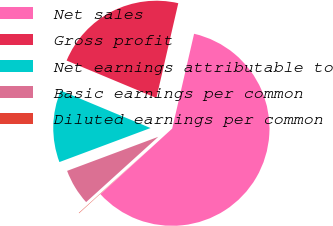Convert chart to OTSL. <chart><loc_0><loc_0><loc_500><loc_500><pie_chart><fcel>Net sales<fcel>Gross profit<fcel>Net earnings attributable to<fcel>Basic earnings per common<fcel>Diluted earnings per common<nl><fcel>59.61%<fcel>22.32%<fcel>11.98%<fcel>6.02%<fcel>0.07%<nl></chart> 